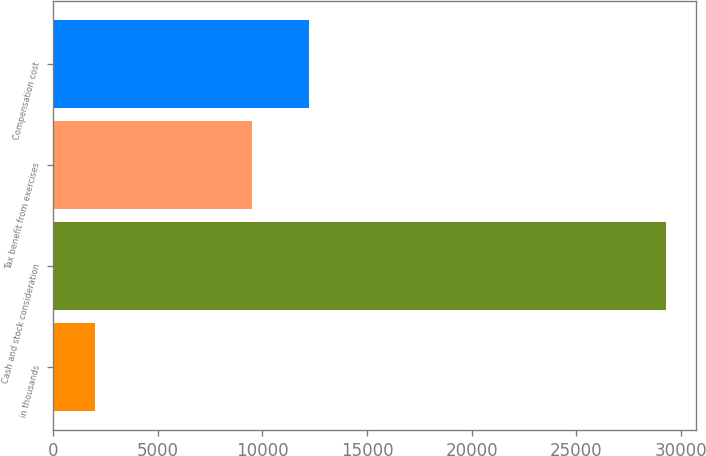Convert chart to OTSL. <chart><loc_0><loc_0><loc_500><loc_500><bar_chart><fcel>in thousands<fcel>Cash and stock consideration<fcel>Tax benefit from exercises<fcel>Compensation cost<nl><fcel>2008<fcel>29278<fcel>9502<fcel>12229<nl></chart> 